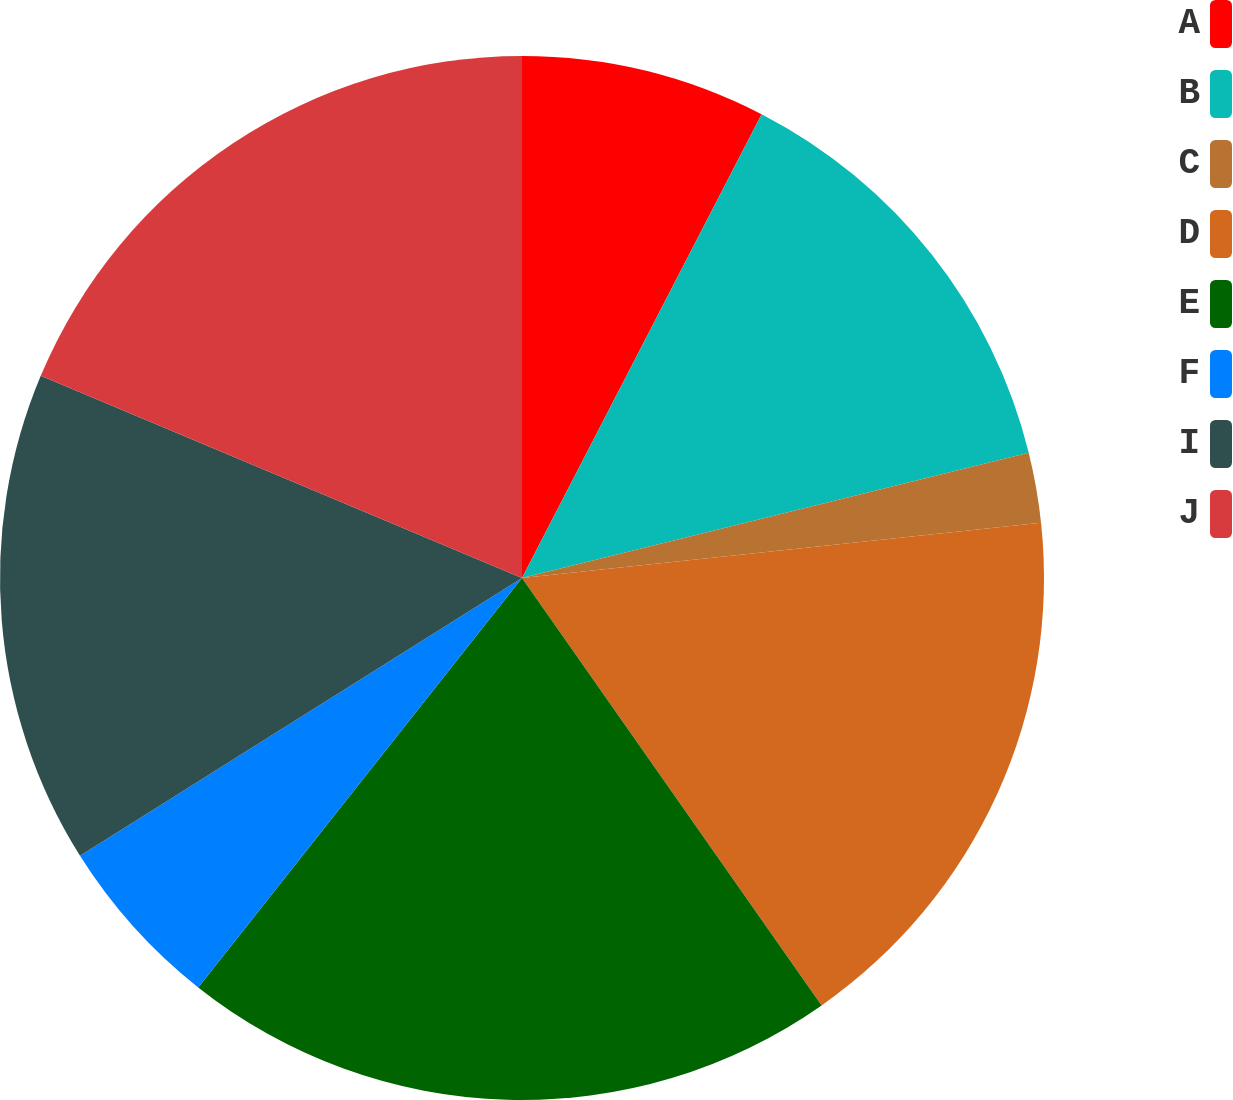Convert chart to OTSL. <chart><loc_0><loc_0><loc_500><loc_500><pie_chart><fcel>A<fcel>B<fcel>C<fcel>D<fcel>E<fcel>F<fcel>I<fcel>J<nl><fcel>7.59%<fcel>13.55%<fcel>2.17%<fcel>16.96%<fcel>20.38%<fcel>5.42%<fcel>15.26%<fcel>18.67%<nl></chart> 